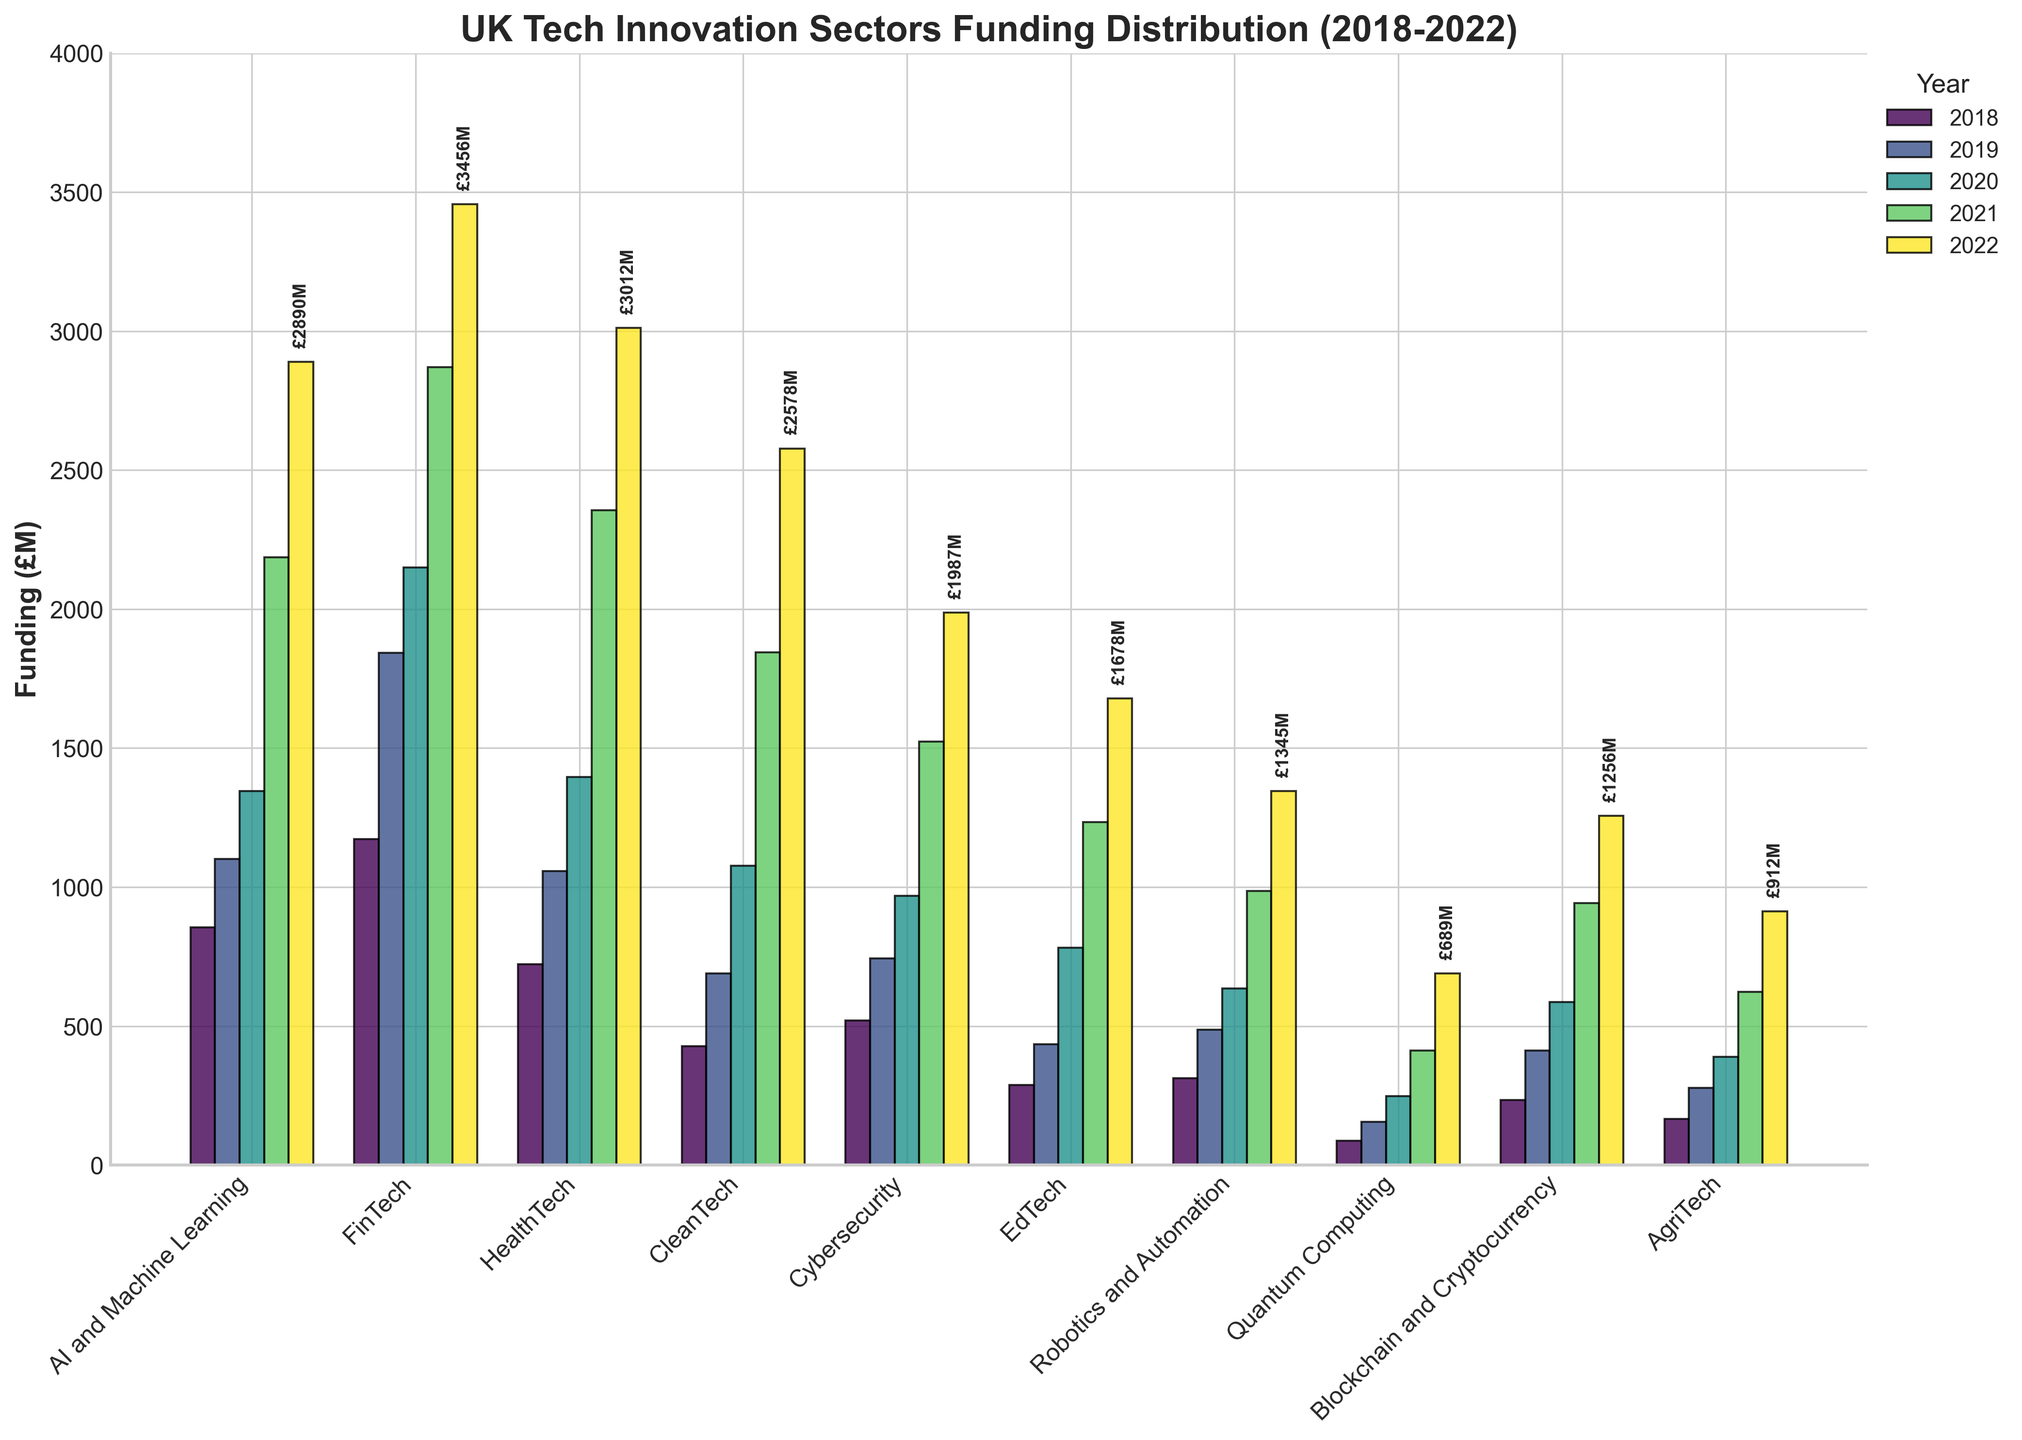Which sector received the highest amount of funding in 2022? Look at the heights of the bars for 2022. The tallest bar represents the sector with the highest funding.
Answer: FinTech How did the funding for AI and Machine Learning change between 2018 and 2022? Compare the height of the bars for AI and Machine Learning from 2018 to 2022. The funding increased from 856 (£M) in 2018 to 2890 (£M) in 2022.
Answer: It increased Which sector had the smallest funding amount in 2019? Observe the bars corresponding to 2019 and identify the shortest one.
Answer: Quantum Computing What is the overall trend of funding from 2018 to 2022 in the HealthTech sector? Look at the bar heights for HealthTech from 2018 to 2022, which show a consistent upward trend.
Answer: Increasing Compare the funding in 2020 for Cybersecurity and EdTech sectors. Which one had higher funding? Compare the height of the 2020 bar for Cybersecurity to the one for EdTech.
Answer: Cybersecurity What is the difference in funding between CleanTech and AgriTech in 2022? Subtract the funding for AgriTech from CleanTech for 2022. CleanTech had 2578 (£M) and AgriTech had 912 (£M). The difference is 2578 - 912.
Answer: 1666 (£M) How does the funding for Blockchain and Cryptocurrency in 2019 compare to its funding in 2022? Compare the height of the bars for Blockchain and Cryptocurrency in 2019 and 2022. The funding increased from 412 (£M) in 2019 to 1256 (£M) in 2022.
Answer: Increased What is the average funding for Robotics and Automation from 2018 to 2022? Sum the funding from 2018 to 2022 for Robotics and Automation, then divide by 5. The funding amounts are 312, 487, 635, 987, and 1345 (£M). The total is 3766 (£M), so the average is 3766 / 5.
Answer: 753.2 (£M) In which year did FinTech see its highest funding? Look at the bar heights for each year in the FinTech sector. The highest bar is for 2022.
Answer: 2022 What visual pattern can be observed for sectors with increasing funding trends between 2018 and 2022? Visually, you can observe sectors with bars that steadily increase in height from left to right across the years. Examples include AI and Machine Learning, FinTech, and HealthTech.
Answer: Increasing bar heights across years 